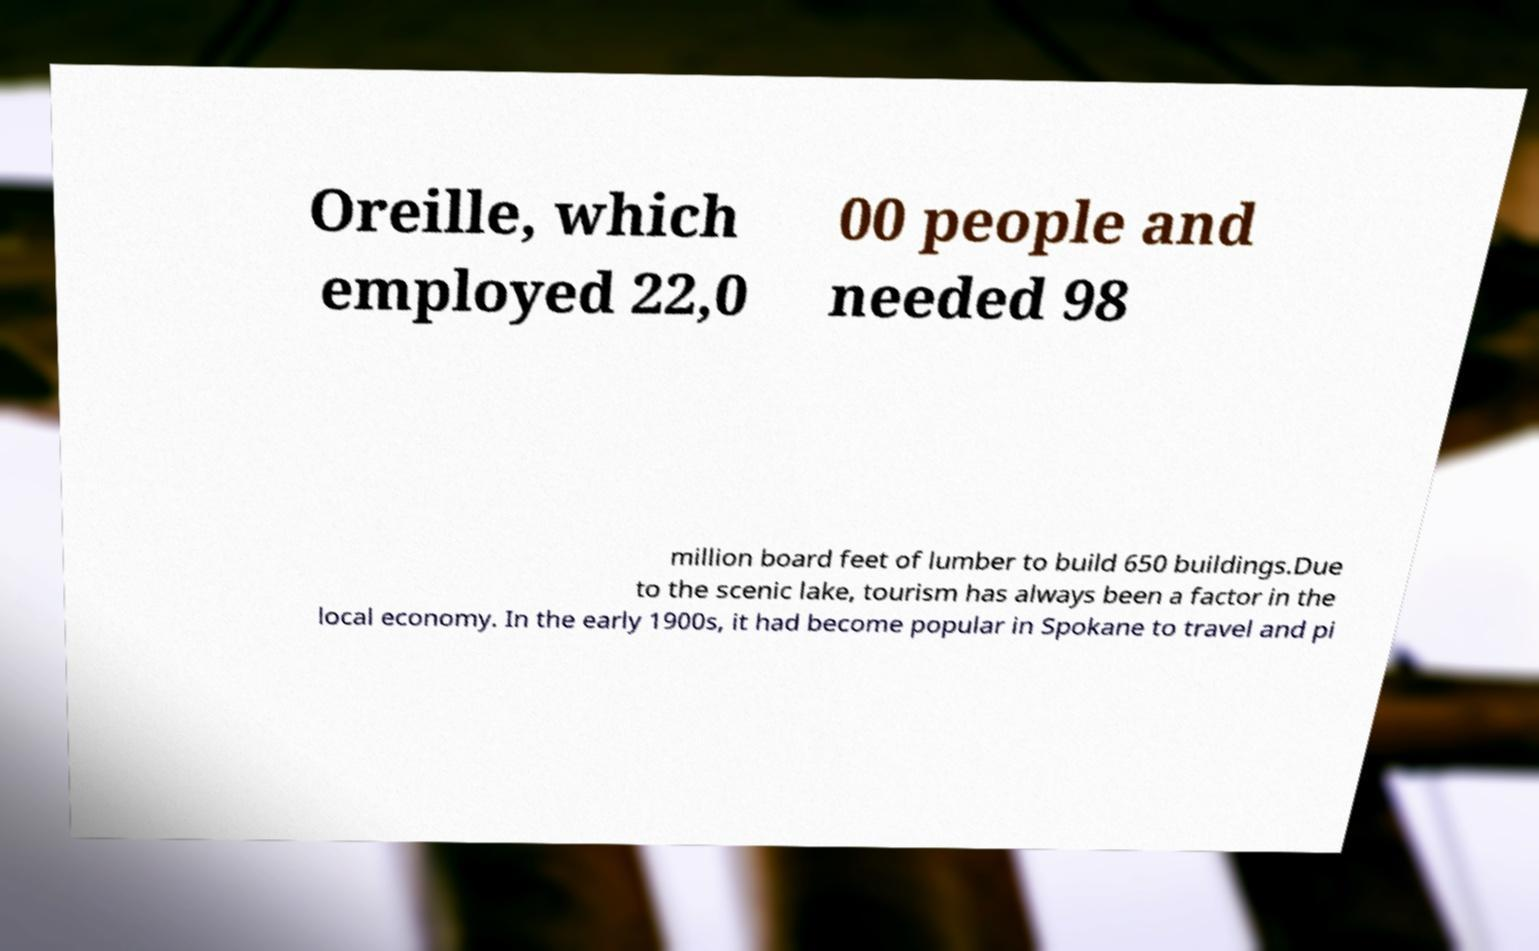Could you assist in decoding the text presented in this image and type it out clearly? Oreille, which employed 22,0 00 people and needed 98 million board feet of lumber to build 650 buildings.Due to the scenic lake, tourism has always been a factor in the local economy. In the early 1900s, it had become popular in Spokane to travel and pi 